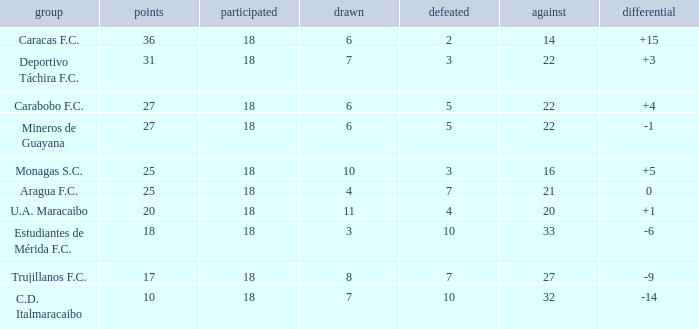What is the lowest number of points of any team with less than 6 draws and less than 18 matches played? None. 